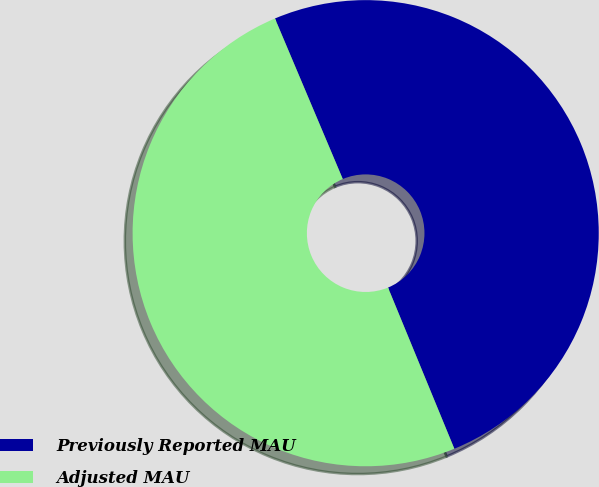<chart> <loc_0><loc_0><loc_500><loc_500><pie_chart><fcel>Previously Reported MAU<fcel>Adjusted MAU<nl><fcel>50.15%<fcel>49.85%<nl></chart> 